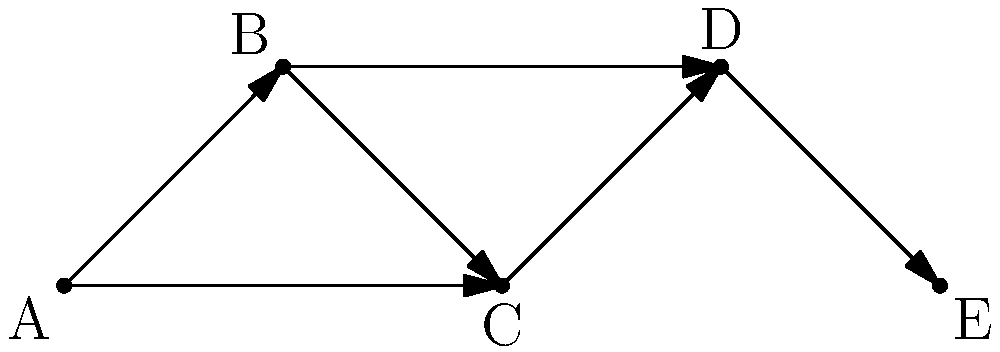In the graph representing corporate acquisitions over time, where each node represents a company and each directed edge represents an acquisition, what is the maximum number of companies that could have existed independently at the beginning, assuming no companies were created during this period? To determine the maximum number of companies that could have existed independently at the beginning, we need to analyze the graph's structure and the nature of acquisitions:

1. First, identify the nodes with no incoming edges (sources). These represent companies that were not acquired by any other company in the graph.

2. In this graph, we see that node A has no incoming edges, making it a definite source.

3. Next, we need to consider the possibility of other nodes being sources. While they have incoming edges, some of these acquisitions might have happened later in time.

4. The maximum number of sources would occur if we assume that each company made only one acquisition, and did so in a specific order that allows for the most initial independent companies.

5. Following this logic, we can trace back the acquisitions:
   - E could have been independent initially, then acquired by D
   - D could have been independent initially, then acquired C after acquiring E
   - C could have been independent initially, then acquired by B after its acquisition of D
   - B could have been independent initially

6. This interpretation allows for the maximum number of initially independent companies while still satisfying the graph structure.

Therefore, the maximum number of companies that could have existed independently at the beginning is 5 (A, B, C, D, and E).
Answer: 5 